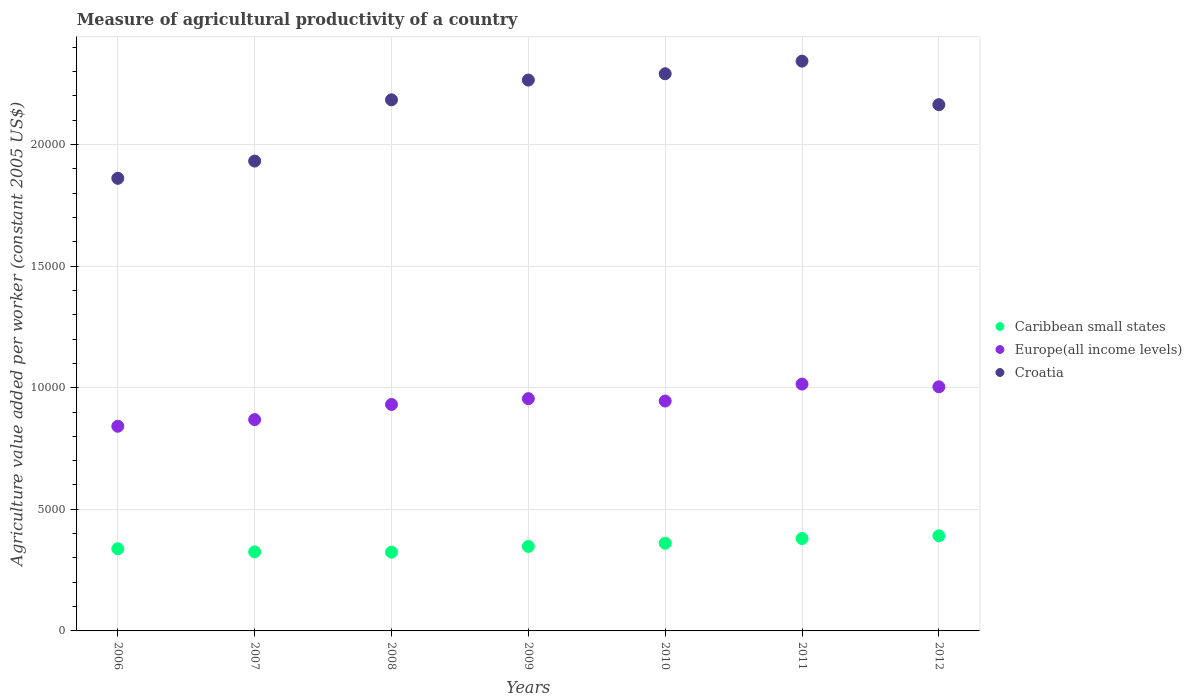How many different coloured dotlines are there?
Keep it short and to the point. 3. What is the measure of agricultural productivity in Europe(all income levels) in 2011?
Provide a succinct answer. 1.01e+04. Across all years, what is the maximum measure of agricultural productivity in Croatia?
Give a very brief answer. 2.34e+04. Across all years, what is the minimum measure of agricultural productivity in Croatia?
Provide a short and direct response. 1.86e+04. In which year was the measure of agricultural productivity in Croatia maximum?
Give a very brief answer. 2011. In which year was the measure of agricultural productivity in Croatia minimum?
Provide a succinct answer. 2006. What is the total measure of agricultural productivity in Caribbean small states in the graph?
Provide a short and direct response. 2.47e+04. What is the difference between the measure of agricultural productivity in Caribbean small states in 2006 and that in 2010?
Ensure brevity in your answer.  -224.67. What is the difference between the measure of agricultural productivity in Europe(all income levels) in 2006 and the measure of agricultural productivity in Caribbean small states in 2010?
Keep it short and to the point. 4811.52. What is the average measure of agricultural productivity in Europe(all income levels) per year?
Offer a very short reply. 9371.92. In the year 2006, what is the difference between the measure of agricultural productivity in Caribbean small states and measure of agricultural productivity in Europe(all income levels)?
Provide a short and direct response. -5036.19. In how many years, is the measure of agricultural productivity in Europe(all income levels) greater than 21000 US$?
Provide a succinct answer. 0. What is the ratio of the measure of agricultural productivity in Croatia in 2008 to that in 2012?
Give a very brief answer. 1.01. Is the measure of agricultural productivity in Europe(all income levels) in 2007 less than that in 2011?
Ensure brevity in your answer.  Yes. Is the difference between the measure of agricultural productivity in Caribbean small states in 2007 and 2010 greater than the difference between the measure of agricultural productivity in Europe(all income levels) in 2007 and 2010?
Keep it short and to the point. Yes. What is the difference between the highest and the second highest measure of agricultural productivity in Caribbean small states?
Offer a terse response. 111.31. What is the difference between the highest and the lowest measure of agricultural productivity in Europe(all income levels)?
Provide a short and direct response. 1733.67. Is the sum of the measure of agricultural productivity in Caribbean small states in 2007 and 2011 greater than the maximum measure of agricultural productivity in Croatia across all years?
Offer a terse response. No. Is it the case that in every year, the sum of the measure of agricultural productivity in Caribbean small states and measure of agricultural productivity in Europe(all income levels)  is greater than the measure of agricultural productivity in Croatia?
Make the answer very short. No. Is the measure of agricultural productivity in Europe(all income levels) strictly greater than the measure of agricultural productivity in Caribbean small states over the years?
Your answer should be very brief. Yes. Is the measure of agricultural productivity in Europe(all income levels) strictly less than the measure of agricultural productivity in Croatia over the years?
Make the answer very short. Yes. How many years are there in the graph?
Ensure brevity in your answer.  7. Are the values on the major ticks of Y-axis written in scientific E-notation?
Offer a very short reply. No. Does the graph contain grids?
Offer a terse response. Yes. How many legend labels are there?
Your answer should be compact. 3. What is the title of the graph?
Offer a terse response. Measure of agricultural productivity of a country. Does "Tanzania" appear as one of the legend labels in the graph?
Ensure brevity in your answer.  No. What is the label or title of the Y-axis?
Offer a very short reply. Agriculture value added per worker (constant 2005 US$). What is the Agriculture value added per worker (constant 2005 US$) of Caribbean small states in 2006?
Offer a very short reply. 3379.18. What is the Agriculture value added per worker (constant 2005 US$) in Europe(all income levels) in 2006?
Offer a terse response. 8415.37. What is the Agriculture value added per worker (constant 2005 US$) of Croatia in 2006?
Provide a short and direct response. 1.86e+04. What is the Agriculture value added per worker (constant 2005 US$) of Caribbean small states in 2007?
Offer a very short reply. 3251.7. What is the Agriculture value added per worker (constant 2005 US$) of Europe(all income levels) in 2007?
Give a very brief answer. 8688.61. What is the Agriculture value added per worker (constant 2005 US$) in Croatia in 2007?
Offer a very short reply. 1.93e+04. What is the Agriculture value added per worker (constant 2005 US$) of Caribbean small states in 2008?
Keep it short and to the point. 3238. What is the Agriculture value added per worker (constant 2005 US$) in Europe(all income levels) in 2008?
Your answer should be very brief. 9311.42. What is the Agriculture value added per worker (constant 2005 US$) in Croatia in 2008?
Provide a succinct answer. 2.18e+04. What is the Agriculture value added per worker (constant 2005 US$) of Caribbean small states in 2009?
Offer a very short reply. 3474.01. What is the Agriculture value added per worker (constant 2005 US$) of Europe(all income levels) in 2009?
Make the answer very short. 9549.65. What is the Agriculture value added per worker (constant 2005 US$) in Croatia in 2009?
Keep it short and to the point. 2.26e+04. What is the Agriculture value added per worker (constant 2005 US$) in Caribbean small states in 2010?
Offer a very short reply. 3603.85. What is the Agriculture value added per worker (constant 2005 US$) in Europe(all income levels) in 2010?
Provide a succinct answer. 9451.91. What is the Agriculture value added per worker (constant 2005 US$) of Croatia in 2010?
Give a very brief answer. 2.29e+04. What is the Agriculture value added per worker (constant 2005 US$) in Caribbean small states in 2011?
Make the answer very short. 3799.12. What is the Agriculture value added per worker (constant 2005 US$) of Europe(all income levels) in 2011?
Provide a short and direct response. 1.01e+04. What is the Agriculture value added per worker (constant 2005 US$) of Croatia in 2011?
Ensure brevity in your answer.  2.34e+04. What is the Agriculture value added per worker (constant 2005 US$) of Caribbean small states in 2012?
Give a very brief answer. 3910.42. What is the Agriculture value added per worker (constant 2005 US$) in Europe(all income levels) in 2012?
Your answer should be compact. 1.00e+04. What is the Agriculture value added per worker (constant 2005 US$) in Croatia in 2012?
Keep it short and to the point. 2.16e+04. Across all years, what is the maximum Agriculture value added per worker (constant 2005 US$) in Caribbean small states?
Your answer should be very brief. 3910.42. Across all years, what is the maximum Agriculture value added per worker (constant 2005 US$) of Europe(all income levels)?
Your answer should be compact. 1.01e+04. Across all years, what is the maximum Agriculture value added per worker (constant 2005 US$) in Croatia?
Your answer should be very brief. 2.34e+04. Across all years, what is the minimum Agriculture value added per worker (constant 2005 US$) in Caribbean small states?
Your response must be concise. 3238. Across all years, what is the minimum Agriculture value added per worker (constant 2005 US$) of Europe(all income levels)?
Make the answer very short. 8415.37. Across all years, what is the minimum Agriculture value added per worker (constant 2005 US$) in Croatia?
Your response must be concise. 1.86e+04. What is the total Agriculture value added per worker (constant 2005 US$) in Caribbean small states in the graph?
Ensure brevity in your answer.  2.47e+04. What is the total Agriculture value added per worker (constant 2005 US$) of Europe(all income levels) in the graph?
Your answer should be very brief. 6.56e+04. What is the total Agriculture value added per worker (constant 2005 US$) of Croatia in the graph?
Your answer should be compact. 1.50e+05. What is the difference between the Agriculture value added per worker (constant 2005 US$) of Caribbean small states in 2006 and that in 2007?
Make the answer very short. 127.48. What is the difference between the Agriculture value added per worker (constant 2005 US$) in Europe(all income levels) in 2006 and that in 2007?
Ensure brevity in your answer.  -273.24. What is the difference between the Agriculture value added per worker (constant 2005 US$) of Croatia in 2006 and that in 2007?
Provide a short and direct response. -709.26. What is the difference between the Agriculture value added per worker (constant 2005 US$) in Caribbean small states in 2006 and that in 2008?
Make the answer very short. 141.18. What is the difference between the Agriculture value added per worker (constant 2005 US$) in Europe(all income levels) in 2006 and that in 2008?
Your response must be concise. -896.05. What is the difference between the Agriculture value added per worker (constant 2005 US$) in Croatia in 2006 and that in 2008?
Your answer should be very brief. -3228.09. What is the difference between the Agriculture value added per worker (constant 2005 US$) of Caribbean small states in 2006 and that in 2009?
Your response must be concise. -94.83. What is the difference between the Agriculture value added per worker (constant 2005 US$) in Europe(all income levels) in 2006 and that in 2009?
Ensure brevity in your answer.  -1134.28. What is the difference between the Agriculture value added per worker (constant 2005 US$) of Croatia in 2006 and that in 2009?
Provide a short and direct response. -4039.77. What is the difference between the Agriculture value added per worker (constant 2005 US$) of Caribbean small states in 2006 and that in 2010?
Your answer should be compact. -224.67. What is the difference between the Agriculture value added per worker (constant 2005 US$) of Europe(all income levels) in 2006 and that in 2010?
Ensure brevity in your answer.  -1036.53. What is the difference between the Agriculture value added per worker (constant 2005 US$) in Croatia in 2006 and that in 2010?
Offer a very short reply. -4298.87. What is the difference between the Agriculture value added per worker (constant 2005 US$) of Caribbean small states in 2006 and that in 2011?
Provide a short and direct response. -419.94. What is the difference between the Agriculture value added per worker (constant 2005 US$) of Europe(all income levels) in 2006 and that in 2011?
Your answer should be very brief. -1733.67. What is the difference between the Agriculture value added per worker (constant 2005 US$) of Croatia in 2006 and that in 2011?
Your response must be concise. -4818.42. What is the difference between the Agriculture value added per worker (constant 2005 US$) of Caribbean small states in 2006 and that in 2012?
Your answer should be compact. -531.24. What is the difference between the Agriculture value added per worker (constant 2005 US$) in Europe(all income levels) in 2006 and that in 2012?
Your answer should be compact. -1622.05. What is the difference between the Agriculture value added per worker (constant 2005 US$) of Croatia in 2006 and that in 2012?
Provide a succinct answer. -3028.24. What is the difference between the Agriculture value added per worker (constant 2005 US$) in Caribbean small states in 2007 and that in 2008?
Offer a very short reply. 13.7. What is the difference between the Agriculture value added per worker (constant 2005 US$) in Europe(all income levels) in 2007 and that in 2008?
Your response must be concise. -622.81. What is the difference between the Agriculture value added per worker (constant 2005 US$) in Croatia in 2007 and that in 2008?
Offer a very short reply. -2518.83. What is the difference between the Agriculture value added per worker (constant 2005 US$) in Caribbean small states in 2007 and that in 2009?
Your answer should be very brief. -222.31. What is the difference between the Agriculture value added per worker (constant 2005 US$) in Europe(all income levels) in 2007 and that in 2009?
Ensure brevity in your answer.  -861.04. What is the difference between the Agriculture value added per worker (constant 2005 US$) in Croatia in 2007 and that in 2009?
Make the answer very short. -3330.51. What is the difference between the Agriculture value added per worker (constant 2005 US$) in Caribbean small states in 2007 and that in 2010?
Offer a very short reply. -352.15. What is the difference between the Agriculture value added per worker (constant 2005 US$) of Europe(all income levels) in 2007 and that in 2010?
Offer a terse response. -763.3. What is the difference between the Agriculture value added per worker (constant 2005 US$) in Croatia in 2007 and that in 2010?
Keep it short and to the point. -3589.61. What is the difference between the Agriculture value added per worker (constant 2005 US$) in Caribbean small states in 2007 and that in 2011?
Give a very brief answer. -547.41. What is the difference between the Agriculture value added per worker (constant 2005 US$) of Europe(all income levels) in 2007 and that in 2011?
Offer a terse response. -1460.43. What is the difference between the Agriculture value added per worker (constant 2005 US$) of Croatia in 2007 and that in 2011?
Your response must be concise. -4109.16. What is the difference between the Agriculture value added per worker (constant 2005 US$) in Caribbean small states in 2007 and that in 2012?
Offer a terse response. -658.72. What is the difference between the Agriculture value added per worker (constant 2005 US$) in Europe(all income levels) in 2007 and that in 2012?
Offer a very short reply. -1348.81. What is the difference between the Agriculture value added per worker (constant 2005 US$) of Croatia in 2007 and that in 2012?
Make the answer very short. -2318.98. What is the difference between the Agriculture value added per worker (constant 2005 US$) in Caribbean small states in 2008 and that in 2009?
Provide a short and direct response. -236.01. What is the difference between the Agriculture value added per worker (constant 2005 US$) of Europe(all income levels) in 2008 and that in 2009?
Keep it short and to the point. -238.23. What is the difference between the Agriculture value added per worker (constant 2005 US$) in Croatia in 2008 and that in 2009?
Ensure brevity in your answer.  -811.68. What is the difference between the Agriculture value added per worker (constant 2005 US$) in Caribbean small states in 2008 and that in 2010?
Keep it short and to the point. -365.85. What is the difference between the Agriculture value added per worker (constant 2005 US$) of Europe(all income levels) in 2008 and that in 2010?
Keep it short and to the point. -140.49. What is the difference between the Agriculture value added per worker (constant 2005 US$) in Croatia in 2008 and that in 2010?
Make the answer very short. -1070.77. What is the difference between the Agriculture value added per worker (constant 2005 US$) in Caribbean small states in 2008 and that in 2011?
Your response must be concise. -561.12. What is the difference between the Agriculture value added per worker (constant 2005 US$) in Europe(all income levels) in 2008 and that in 2011?
Ensure brevity in your answer.  -837.62. What is the difference between the Agriculture value added per worker (constant 2005 US$) of Croatia in 2008 and that in 2011?
Offer a very short reply. -1590.33. What is the difference between the Agriculture value added per worker (constant 2005 US$) in Caribbean small states in 2008 and that in 2012?
Your response must be concise. -672.42. What is the difference between the Agriculture value added per worker (constant 2005 US$) in Europe(all income levels) in 2008 and that in 2012?
Make the answer very short. -726. What is the difference between the Agriculture value added per worker (constant 2005 US$) in Croatia in 2008 and that in 2012?
Provide a short and direct response. 199.86. What is the difference between the Agriculture value added per worker (constant 2005 US$) in Caribbean small states in 2009 and that in 2010?
Make the answer very short. -129.84. What is the difference between the Agriculture value added per worker (constant 2005 US$) of Europe(all income levels) in 2009 and that in 2010?
Your response must be concise. 97.74. What is the difference between the Agriculture value added per worker (constant 2005 US$) in Croatia in 2009 and that in 2010?
Provide a succinct answer. -259.09. What is the difference between the Agriculture value added per worker (constant 2005 US$) of Caribbean small states in 2009 and that in 2011?
Your response must be concise. -325.1. What is the difference between the Agriculture value added per worker (constant 2005 US$) in Europe(all income levels) in 2009 and that in 2011?
Your answer should be compact. -599.39. What is the difference between the Agriculture value added per worker (constant 2005 US$) of Croatia in 2009 and that in 2011?
Your response must be concise. -778.64. What is the difference between the Agriculture value added per worker (constant 2005 US$) in Caribbean small states in 2009 and that in 2012?
Provide a succinct answer. -436.41. What is the difference between the Agriculture value added per worker (constant 2005 US$) in Europe(all income levels) in 2009 and that in 2012?
Your answer should be very brief. -487.77. What is the difference between the Agriculture value added per worker (constant 2005 US$) in Croatia in 2009 and that in 2012?
Ensure brevity in your answer.  1011.54. What is the difference between the Agriculture value added per worker (constant 2005 US$) in Caribbean small states in 2010 and that in 2011?
Offer a very short reply. -195.27. What is the difference between the Agriculture value added per worker (constant 2005 US$) of Europe(all income levels) in 2010 and that in 2011?
Give a very brief answer. -697.13. What is the difference between the Agriculture value added per worker (constant 2005 US$) in Croatia in 2010 and that in 2011?
Your response must be concise. -519.55. What is the difference between the Agriculture value added per worker (constant 2005 US$) in Caribbean small states in 2010 and that in 2012?
Make the answer very short. -306.57. What is the difference between the Agriculture value added per worker (constant 2005 US$) in Europe(all income levels) in 2010 and that in 2012?
Provide a short and direct response. -585.51. What is the difference between the Agriculture value added per worker (constant 2005 US$) of Croatia in 2010 and that in 2012?
Make the answer very short. 1270.63. What is the difference between the Agriculture value added per worker (constant 2005 US$) in Caribbean small states in 2011 and that in 2012?
Offer a very short reply. -111.31. What is the difference between the Agriculture value added per worker (constant 2005 US$) in Europe(all income levels) in 2011 and that in 2012?
Keep it short and to the point. 111.62. What is the difference between the Agriculture value added per worker (constant 2005 US$) in Croatia in 2011 and that in 2012?
Give a very brief answer. 1790.18. What is the difference between the Agriculture value added per worker (constant 2005 US$) in Caribbean small states in 2006 and the Agriculture value added per worker (constant 2005 US$) in Europe(all income levels) in 2007?
Your answer should be very brief. -5309.43. What is the difference between the Agriculture value added per worker (constant 2005 US$) in Caribbean small states in 2006 and the Agriculture value added per worker (constant 2005 US$) in Croatia in 2007?
Give a very brief answer. -1.59e+04. What is the difference between the Agriculture value added per worker (constant 2005 US$) of Europe(all income levels) in 2006 and the Agriculture value added per worker (constant 2005 US$) of Croatia in 2007?
Your answer should be very brief. -1.09e+04. What is the difference between the Agriculture value added per worker (constant 2005 US$) of Caribbean small states in 2006 and the Agriculture value added per worker (constant 2005 US$) of Europe(all income levels) in 2008?
Give a very brief answer. -5932.24. What is the difference between the Agriculture value added per worker (constant 2005 US$) in Caribbean small states in 2006 and the Agriculture value added per worker (constant 2005 US$) in Croatia in 2008?
Provide a succinct answer. -1.85e+04. What is the difference between the Agriculture value added per worker (constant 2005 US$) in Europe(all income levels) in 2006 and the Agriculture value added per worker (constant 2005 US$) in Croatia in 2008?
Give a very brief answer. -1.34e+04. What is the difference between the Agriculture value added per worker (constant 2005 US$) of Caribbean small states in 2006 and the Agriculture value added per worker (constant 2005 US$) of Europe(all income levels) in 2009?
Your answer should be very brief. -6170.47. What is the difference between the Agriculture value added per worker (constant 2005 US$) of Caribbean small states in 2006 and the Agriculture value added per worker (constant 2005 US$) of Croatia in 2009?
Provide a succinct answer. -1.93e+04. What is the difference between the Agriculture value added per worker (constant 2005 US$) of Europe(all income levels) in 2006 and the Agriculture value added per worker (constant 2005 US$) of Croatia in 2009?
Give a very brief answer. -1.42e+04. What is the difference between the Agriculture value added per worker (constant 2005 US$) in Caribbean small states in 2006 and the Agriculture value added per worker (constant 2005 US$) in Europe(all income levels) in 2010?
Offer a terse response. -6072.73. What is the difference between the Agriculture value added per worker (constant 2005 US$) in Caribbean small states in 2006 and the Agriculture value added per worker (constant 2005 US$) in Croatia in 2010?
Offer a terse response. -1.95e+04. What is the difference between the Agriculture value added per worker (constant 2005 US$) in Europe(all income levels) in 2006 and the Agriculture value added per worker (constant 2005 US$) in Croatia in 2010?
Offer a terse response. -1.45e+04. What is the difference between the Agriculture value added per worker (constant 2005 US$) in Caribbean small states in 2006 and the Agriculture value added per worker (constant 2005 US$) in Europe(all income levels) in 2011?
Make the answer very short. -6769.86. What is the difference between the Agriculture value added per worker (constant 2005 US$) in Caribbean small states in 2006 and the Agriculture value added per worker (constant 2005 US$) in Croatia in 2011?
Your answer should be compact. -2.00e+04. What is the difference between the Agriculture value added per worker (constant 2005 US$) of Europe(all income levels) in 2006 and the Agriculture value added per worker (constant 2005 US$) of Croatia in 2011?
Offer a very short reply. -1.50e+04. What is the difference between the Agriculture value added per worker (constant 2005 US$) in Caribbean small states in 2006 and the Agriculture value added per worker (constant 2005 US$) in Europe(all income levels) in 2012?
Offer a very short reply. -6658.24. What is the difference between the Agriculture value added per worker (constant 2005 US$) of Caribbean small states in 2006 and the Agriculture value added per worker (constant 2005 US$) of Croatia in 2012?
Keep it short and to the point. -1.83e+04. What is the difference between the Agriculture value added per worker (constant 2005 US$) of Europe(all income levels) in 2006 and the Agriculture value added per worker (constant 2005 US$) of Croatia in 2012?
Provide a short and direct response. -1.32e+04. What is the difference between the Agriculture value added per worker (constant 2005 US$) of Caribbean small states in 2007 and the Agriculture value added per worker (constant 2005 US$) of Europe(all income levels) in 2008?
Your answer should be compact. -6059.72. What is the difference between the Agriculture value added per worker (constant 2005 US$) of Caribbean small states in 2007 and the Agriculture value added per worker (constant 2005 US$) of Croatia in 2008?
Give a very brief answer. -1.86e+04. What is the difference between the Agriculture value added per worker (constant 2005 US$) in Europe(all income levels) in 2007 and the Agriculture value added per worker (constant 2005 US$) in Croatia in 2008?
Keep it short and to the point. -1.31e+04. What is the difference between the Agriculture value added per worker (constant 2005 US$) of Caribbean small states in 2007 and the Agriculture value added per worker (constant 2005 US$) of Europe(all income levels) in 2009?
Make the answer very short. -6297.95. What is the difference between the Agriculture value added per worker (constant 2005 US$) of Caribbean small states in 2007 and the Agriculture value added per worker (constant 2005 US$) of Croatia in 2009?
Your response must be concise. -1.94e+04. What is the difference between the Agriculture value added per worker (constant 2005 US$) in Europe(all income levels) in 2007 and the Agriculture value added per worker (constant 2005 US$) in Croatia in 2009?
Keep it short and to the point. -1.40e+04. What is the difference between the Agriculture value added per worker (constant 2005 US$) of Caribbean small states in 2007 and the Agriculture value added per worker (constant 2005 US$) of Europe(all income levels) in 2010?
Keep it short and to the point. -6200.2. What is the difference between the Agriculture value added per worker (constant 2005 US$) in Caribbean small states in 2007 and the Agriculture value added per worker (constant 2005 US$) in Croatia in 2010?
Your answer should be compact. -1.97e+04. What is the difference between the Agriculture value added per worker (constant 2005 US$) in Europe(all income levels) in 2007 and the Agriculture value added per worker (constant 2005 US$) in Croatia in 2010?
Make the answer very short. -1.42e+04. What is the difference between the Agriculture value added per worker (constant 2005 US$) of Caribbean small states in 2007 and the Agriculture value added per worker (constant 2005 US$) of Europe(all income levels) in 2011?
Keep it short and to the point. -6897.34. What is the difference between the Agriculture value added per worker (constant 2005 US$) in Caribbean small states in 2007 and the Agriculture value added per worker (constant 2005 US$) in Croatia in 2011?
Your response must be concise. -2.02e+04. What is the difference between the Agriculture value added per worker (constant 2005 US$) in Europe(all income levels) in 2007 and the Agriculture value added per worker (constant 2005 US$) in Croatia in 2011?
Your answer should be very brief. -1.47e+04. What is the difference between the Agriculture value added per worker (constant 2005 US$) in Caribbean small states in 2007 and the Agriculture value added per worker (constant 2005 US$) in Europe(all income levels) in 2012?
Offer a terse response. -6785.72. What is the difference between the Agriculture value added per worker (constant 2005 US$) in Caribbean small states in 2007 and the Agriculture value added per worker (constant 2005 US$) in Croatia in 2012?
Your answer should be compact. -1.84e+04. What is the difference between the Agriculture value added per worker (constant 2005 US$) of Europe(all income levels) in 2007 and the Agriculture value added per worker (constant 2005 US$) of Croatia in 2012?
Offer a terse response. -1.29e+04. What is the difference between the Agriculture value added per worker (constant 2005 US$) in Caribbean small states in 2008 and the Agriculture value added per worker (constant 2005 US$) in Europe(all income levels) in 2009?
Provide a succinct answer. -6311.65. What is the difference between the Agriculture value added per worker (constant 2005 US$) in Caribbean small states in 2008 and the Agriculture value added per worker (constant 2005 US$) in Croatia in 2009?
Keep it short and to the point. -1.94e+04. What is the difference between the Agriculture value added per worker (constant 2005 US$) of Europe(all income levels) in 2008 and the Agriculture value added per worker (constant 2005 US$) of Croatia in 2009?
Ensure brevity in your answer.  -1.33e+04. What is the difference between the Agriculture value added per worker (constant 2005 US$) of Caribbean small states in 2008 and the Agriculture value added per worker (constant 2005 US$) of Europe(all income levels) in 2010?
Ensure brevity in your answer.  -6213.91. What is the difference between the Agriculture value added per worker (constant 2005 US$) of Caribbean small states in 2008 and the Agriculture value added per worker (constant 2005 US$) of Croatia in 2010?
Keep it short and to the point. -1.97e+04. What is the difference between the Agriculture value added per worker (constant 2005 US$) in Europe(all income levels) in 2008 and the Agriculture value added per worker (constant 2005 US$) in Croatia in 2010?
Your answer should be compact. -1.36e+04. What is the difference between the Agriculture value added per worker (constant 2005 US$) of Caribbean small states in 2008 and the Agriculture value added per worker (constant 2005 US$) of Europe(all income levels) in 2011?
Give a very brief answer. -6911.04. What is the difference between the Agriculture value added per worker (constant 2005 US$) in Caribbean small states in 2008 and the Agriculture value added per worker (constant 2005 US$) in Croatia in 2011?
Provide a succinct answer. -2.02e+04. What is the difference between the Agriculture value added per worker (constant 2005 US$) of Europe(all income levels) in 2008 and the Agriculture value added per worker (constant 2005 US$) of Croatia in 2011?
Give a very brief answer. -1.41e+04. What is the difference between the Agriculture value added per worker (constant 2005 US$) in Caribbean small states in 2008 and the Agriculture value added per worker (constant 2005 US$) in Europe(all income levels) in 2012?
Offer a very short reply. -6799.42. What is the difference between the Agriculture value added per worker (constant 2005 US$) in Caribbean small states in 2008 and the Agriculture value added per worker (constant 2005 US$) in Croatia in 2012?
Ensure brevity in your answer.  -1.84e+04. What is the difference between the Agriculture value added per worker (constant 2005 US$) of Europe(all income levels) in 2008 and the Agriculture value added per worker (constant 2005 US$) of Croatia in 2012?
Your answer should be very brief. -1.23e+04. What is the difference between the Agriculture value added per worker (constant 2005 US$) of Caribbean small states in 2009 and the Agriculture value added per worker (constant 2005 US$) of Europe(all income levels) in 2010?
Provide a short and direct response. -5977.89. What is the difference between the Agriculture value added per worker (constant 2005 US$) of Caribbean small states in 2009 and the Agriculture value added per worker (constant 2005 US$) of Croatia in 2010?
Your answer should be compact. -1.94e+04. What is the difference between the Agriculture value added per worker (constant 2005 US$) in Europe(all income levels) in 2009 and the Agriculture value added per worker (constant 2005 US$) in Croatia in 2010?
Ensure brevity in your answer.  -1.34e+04. What is the difference between the Agriculture value added per worker (constant 2005 US$) in Caribbean small states in 2009 and the Agriculture value added per worker (constant 2005 US$) in Europe(all income levels) in 2011?
Your answer should be very brief. -6675.03. What is the difference between the Agriculture value added per worker (constant 2005 US$) of Caribbean small states in 2009 and the Agriculture value added per worker (constant 2005 US$) of Croatia in 2011?
Offer a terse response. -2.00e+04. What is the difference between the Agriculture value added per worker (constant 2005 US$) of Europe(all income levels) in 2009 and the Agriculture value added per worker (constant 2005 US$) of Croatia in 2011?
Provide a succinct answer. -1.39e+04. What is the difference between the Agriculture value added per worker (constant 2005 US$) of Caribbean small states in 2009 and the Agriculture value added per worker (constant 2005 US$) of Europe(all income levels) in 2012?
Keep it short and to the point. -6563.41. What is the difference between the Agriculture value added per worker (constant 2005 US$) of Caribbean small states in 2009 and the Agriculture value added per worker (constant 2005 US$) of Croatia in 2012?
Provide a short and direct response. -1.82e+04. What is the difference between the Agriculture value added per worker (constant 2005 US$) of Europe(all income levels) in 2009 and the Agriculture value added per worker (constant 2005 US$) of Croatia in 2012?
Your answer should be compact. -1.21e+04. What is the difference between the Agriculture value added per worker (constant 2005 US$) in Caribbean small states in 2010 and the Agriculture value added per worker (constant 2005 US$) in Europe(all income levels) in 2011?
Your answer should be very brief. -6545.19. What is the difference between the Agriculture value added per worker (constant 2005 US$) in Caribbean small states in 2010 and the Agriculture value added per worker (constant 2005 US$) in Croatia in 2011?
Offer a terse response. -1.98e+04. What is the difference between the Agriculture value added per worker (constant 2005 US$) in Europe(all income levels) in 2010 and the Agriculture value added per worker (constant 2005 US$) in Croatia in 2011?
Offer a terse response. -1.40e+04. What is the difference between the Agriculture value added per worker (constant 2005 US$) in Caribbean small states in 2010 and the Agriculture value added per worker (constant 2005 US$) in Europe(all income levels) in 2012?
Offer a very short reply. -6433.57. What is the difference between the Agriculture value added per worker (constant 2005 US$) of Caribbean small states in 2010 and the Agriculture value added per worker (constant 2005 US$) of Croatia in 2012?
Offer a terse response. -1.80e+04. What is the difference between the Agriculture value added per worker (constant 2005 US$) in Europe(all income levels) in 2010 and the Agriculture value added per worker (constant 2005 US$) in Croatia in 2012?
Give a very brief answer. -1.22e+04. What is the difference between the Agriculture value added per worker (constant 2005 US$) in Caribbean small states in 2011 and the Agriculture value added per worker (constant 2005 US$) in Europe(all income levels) in 2012?
Give a very brief answer. -6238.31. What is the difference between the Agriculture value added per worker (constant 2005 US$) in Caribbean small states in 2011 and the Agriculture value added per worker (constant 2005 US$) in Croatia in 2012?
Keep it short and to the point. -1.78e+04. What is the difference between the Agriculture value added per worker (constant 2005 US$) in Europe(all income levels) in 2011 and the Agriculture value added per worker (constant 2005 US$) in Croatia in 2012?
Your response must be concise. -1.15e+04. What is the average Agriculture value added per worker (constant 2005 US$) in Caribbean small states per year?
Your answer should be very brief. 3522.33. What is the average Agriculture value added per worker (constant 2005 US$) of Europe(all income levels) per year?
Your answer should be very brief. 9371.92. What is the average Agriculture value added per worker (constant 2005 US$) of Croatia per year?
Make the answer very short. 2.15e+04. In the year 2006, what is the difference between the Agriculture value added per worker (constant 2005 US$) in Caribbean small states and Agriculture value added per worker (constant 2005 US$) in Europe(all income levels)?
Make the answer very short. -5036.19. In the year 2006, what is the difference between the Agriculture value added per worker (constant 2005 US$) in Caribbean small states and Agriculture value added per worker (constant 2005 US$) in Croatia?
Ensure brevity in your answer.  -1.52e+04. In the year 2006, what is the difference between the Agriculture value added per worker (constant 2005 US$) in Europe(all income levels) and Agriculture value added per worker (constant 2005 US$) in Croatia?
Offer a very short reply. -1.02e+04. In the year 2007, what is the difference between the Agriculture value added per worker (constant 2005 US$) in Caribbean small states and Agriculture value added per worker (constant 2005 US$) in Europe(all income levels)?
Your answer should be compact. -5436.91. In the year 2007, what is the difference between the Agriculture value added per worker (constant 2005 US$) in Caribbean small states and Agriculture value added per worker (constant 2005 US$) in Croatia?
Your response must be concise. -1.61e+04. In the year 2007, what is the difference between the Agriculture value added per worker (constant 2005 US$) of Europe(all income levels) and Agriculture value added per worker (constant 2005 US$) of Croatia?
Give a very brief answer. -1.06e+04. In the year 2008, what is the difference between the Agriculture value added per worker (constant 2005 US$) in Caribbean small states and Agriculture value added per worker (constant 2005 US$) in Europe(all income levels)?
Offer a terse response. -6073.42. In the year 2008, what is the difference between the Agriculture value added per worker (constant 2005 US$) of Caribbean small states and Agriculture value added per worker (constant 2005 US$) of Croatia?
Offer a very short reply. -1.86e+04. In the year 2008, what is the difference between the Agriculture value added per worker (constant 2005 US$) in Europe(all income levels) and Agriculture value added per worker (constant 2005 US$) in Croatia?
Provide a succinct answer. -1.25e+04. In the year 2009, what is the difference between the Agriculture value added per worker (constant 2005 US$) in Caribbean small states and Agriculture value added per worker (constant 2005 US$) in Europe(all income levels)?
Your response must be concise. -6075.64. In the year 2009, what is the difference between the Agriculture value added per worker (constant 2005 US$) of Caribbean small states and Agriculture value added per worker (constant 2005 US$) of Croatia?
Keep it short and to the point. -1.92e+04. In the year 2009, what is the difference between the Agriculture value added per worker (constant 2005 US$) in Europe(all income levels) and Agriculture value added per worker (constant 2005 US$) in Croatia?
Your response must be concise. -1.31e+04. In the year 2010, what is the difference between the Agriculture value added per worker (constant 2005 US$) in Caribbean small states and Agriculture value added per worker (constant 2005 US$) in Europe(all income levels)?
Offer a terse response. -5848.06. In the year 2010, what is the difference between the Agriculture value added per worker (constant 2005 US$) of Caribbean small states and Agriculture value added per worker (constant 2005 US$) of Croatia?
Your answer should be compact. -1.93e+04. In the year 2010, what is the difference between the Agriculture value added per worker (constant 2005 US$) of Europe(all income levels) and Agriculture value added per worker (constant 2005 US$) of Croatia?
Give a very brief answer. -1.35e+04. In the year 2011, what is the difference between the Agriculture value added per worker (constant 2005 US$) of Caribbean small states and Agriculture value added per worker (constant 2005 US$) of Europe(all income levels)?
Your answer should be compact. -6349.92. In the year 2011, what is the difference between the Agriculture value added per worker (constant 2005 US$) of Caribbean small states and Agriculture value added per worker (constant 2005 US$) of Croatia?
Offer a terse response. -1.96e+04. In the year 2011, what is the difference between the Agriculture value added per worker (constant 2005 US$) in Europe(all income levels) and Agriculture value added per worker (constant 2005 US$) in Croatia?
Give a very brief answer. -1.33e+04. In the year 2012, what is the difference between the Agriculture value added per worker (constant 2005 US$) of Caribbean small states and Agriculture value added per worker (constant 2005 US$) of Europe(all income levels)?
Keep it short and to the point. -6127. In the year 2012, what is the difference between the Agriculture value added per worker (constant 2005 US$) of Caribbean small states and Agriculture value added per worker (constant 2005 US$) of Croatia?
Your answer should be compact. -1.77e+04. In the year 2012, what is the difference between the Agriculture value added per worker (constant 2005 US$) in Europe(all income levels) and Agriculture value added per worker (constant 2005 US$) in Croatia?
Provide a short and direct response. -1.16e+04. What is the ratio of the Agriculture value added per worker (constant 2005 US$) of Caribbean small states in 2006 to that in 2007?
Offer a very short reply. 1.04. What is the ratio of the Agriculture value added per worker (constant 2005 US$) in Europe(all income levels) in 2006 to that in 2007?
Provide a succinct answer. 0.97. What is the ratio of the Agriculture value added per worker (constant 2005 US$) of Croatia in 2006 to that in 2007?
Offer a very short reply. 0.96. What is the ratio of the Agriculture value added per worker (constant 2005 US$) of Caribbean small states in 2006 to that in 2008?
Give a very brief answer. 1.04. What is the ratio of the Agriculture value added per worker (constant 2005 US$) in Europe(all income levels) in 2006 to that in 2008?
Your answer should be very brief. 0.9. What is the ratio of the Agriculture value added per worker (constant 2005 US$) in Croatia in 2006 to that in 2008?
Offer a very short reply. 0.85. What is the ratio of the Agriculture value added per worker (constant 2005 US$) of Caribbean small states in 2006 to that in 2009?
Make the answer very short. 0.97. What is the ratio of the Agriculture value added per worker (constant 2005 US$) in Europe(all income levels) in 2006 to that in 2009?
Your response must be concise. 0.88. What is the ratio of the Agriculture value added per worker (constant 2005 US$) in Croatia in 2006 to that in 2009?
Offer a terse response. 0.82. What is the ratio of the Agriculture value added per worker (constant 2005 US$) of Caribbean small states in 2006 to that in 2010?
Offer a terse response. 0.94. What is the ratio of the Agriculture value added per worker (constant 2005 US$) of Europe(all income levels) in 2006 to that in 2010?
Give a very brief answer. 0.89. What is the ratio of the Agriculture value added per worker (constant 2005 US$) of Croatia in 2006 to that in 2010?
Your answer should be compact. 0.81. What is the ratio of the Agriculture value added per worker (constant 2005 US$) of Caribbean small states in 2006 to that in 2011?
Offer a very short reply. 0.89. What is the ratio of the Agriculture value added per worker (constant 2005 US$) of Europe(all income levels) in 2006 to that in 2011?
Keep it short and to the point. 0.83. What is the ratio of the Agriculture value added per worker (constant 2005 US$) in Croatia in 2006 to that in 2011?
Your answer should be compact. 0.79. What is the ratio of the Agriculture value added per worker (constant 2005 US$) of Caribbean small states in 2006 to that in 2012?
Offer a very short reply. 0.86. What is the ratio of the Agriculture value added per worker (constant 2005 US$) of Europe(all income levels) in 2006 to that in 2012?
Your response must be concise. 0.84. What is the ratio of the Agriculture value added per worker (constant 2005 US$) of Croatia in 2006 to that in 2012?
Make the answer very short. 0.86. What is the ratio of the Agriculture value added per worker (constant 2005 US$) in Europe(all income levels) in 2007 to that in 2008?
Provide a succinct answer. 0.93. What is the ratio of the Agriculture value added per worker (constant 2005 US$) of Croatia in 2007 to that in 2008?
Offer a very short reply. 0.88. What is the ratio of the Agriculture value added per worker (constant 2005 US$) in Caribbean small states in 2007 to that in 2009?
Make the answer very short. 0.94. What is the ratio of the Agriculture value added per worker (constant 2005 US$) of Europe(all income levels) in 2007 to that in 2009?
Give a very brief answer. 0.91. What is the ratio of the Agriculture value added per worker (constant 2005 US$) in Croatia in 2007 to that in 2009?
Your answer should be compact. 0.85. What is the ratio of the Agriculture value added per worker (constant 2005 US$) of Caribbean small states in 2007 to that in 2010?
Offer a very short reply. 0.9. What is the ratio of the Agriculture value added per worker (constant 2005 US$) in Europe(all income levels) in 2007 to that in 2010?
Offer a terse response. 0.92. What is the ratio of the Agriculture value added per worker (constant 2005 US$) in Croatia in 2007 to that in 2010?
Give a very brief answer. 0.84. What is the ratio of the Agriculture value added per worker (constant 2005 US$) in Caribbean small states in 2007 to that in 2011?
Offer a very short reply. 0.86. What is the ratio of the Agriculture value added per worker (constant 2005 US$) in Europe(all income levels) in 2007 to that in 2011?
Ensure brevity in your answer.  0.86. What is the ratio of the Agriculture value added per worker (constant 2005 US$) in Croatia in 2007 to that in 2011?
Keep it short and to the point. 0.82. What is the ratio of the Agriculture value added per worker (constant 2005 US$) in Caribbean small states in 2007 to that in 2012?
Give a very brief answer. 0.83. What is the ratio of the Agriculture value added per worker (constant 2005 US$) of Europe(all income levels) in 2007 to that in 2012?
Give a very brief answer. 0.87. What is the ratio of the Agriculture value added per worker (constant 2005 US$) in Croatia in 2007 to that in 2012?
Keep it short and to the point. 0.89. What is the ratio of the Agriculture value added per worker (constant 2005 US$) in Caribbean small states in 2008 to that in 2009?
Ensure brevity in your answer.  0.93. What is the ratio of the Agriculture value added per worker (constant 2005 US$) in Europe(all income levels) in 2008 to that in 2009?
Keep it short and to the point. 0.98. What is the ratio of the Agriculture value added per worker (constant 2005 US$) in Croatia in 2008 to that in 2009?
Offer a terse response. 0.96. What is the ratio of the Agriculture value added per worker (constant 2005 US$) in Caribbean small states in 2008 to that in 2010?
Provide a short and direct response. 0.9. What is the ratio of the Agriculture value added per worker (constant 2005 US$) in Europe(all income levels) in 2008 to that in 2010?
Provide a short and direct response. 0.99. What is the ratio of the Agriculture value added per worker (constant 2005 US$) in Croatia in 2008 to that in 2010?
Your answer should be very brief. 0.95. What is the ratio of the Agriculture value added per worker (constant 2005 US$) in Caribbean small states in 2008 to that in 2011?
Keep it short and to the point. 0.85. What is the ratio of the Agriculture value added per worker (constant 2005 US$) in Europe(all income levels) in 2008 to that in 2011?
Your answer should be very brief. 0.92. What is the ratio of the Agriculture value added per worker (constant 2005 US$) in Croatia in 2008 to that in 2011?
Give a very brief answer. 0.93. What is the ratio of the Agriculture value added per worker (constant 2005 US$) in Caribbean small states in 2008 to that in 2012?
Keep it short and to the point. 0.83. What is the ratio of the Agriculture value added per worker (constant 2005 US$) in Europe(all income levels) in 2008 to that in 2012?
Offer a very short reply. 0.93. What is the ratio of the Agriculture value added per worker (constant 2005 US$) in Croatia in 2008 to that in 2012?
Give a very brief answer. 1.01. What is the ratio of the Agriculture value added per worker (constant 2005 US$) of Europe(all income levels) in 2009 to that in 2010?
Offer a very short reply. 1.01. What is the ratio of the Agriculture value added per worker (constant 2005 US$) of Croatia in 2009 to that in 2010?
Provide a short and direct response. 0.99. What is the ratio of the Agriculture value added per worker (constant 2005 US$) of Caribbean small states in 2009 to that in 2011?
Your response must be concise. 0.91. What is the ratio of the Agriculture value added per worker (constant 2005 US$) in Europe(all income levels) in 2009 to that in 2011?
Provide a succinct answer. 0.94. What is the ratio of the Agriculture value added per worker (constant 2005 US$) in Croatia in 2009 to that in 2011?
Your response must be concise. 0.97. What is the ratio of the Agriculture value added per worker (constant 2005 US$) in Caribbean small states in 2009 to that in 2012?
Your answer should be compact. 0.89. What is the ratio of the Agriculture value added per worker (constant 2005 US$) in Europe(all income levels) in 2009 to that in 2012?
Offer a very short reply. 0.95. What is the ratio of the Agriculture value added per worker (constant 2005 US$) in Croatia in 2009 to that in 2012?
Offer a terse response. 1.05. What is the ratio of the Agriculture value added per worker (constant 2005 US$) of Caribbean small states in 2010 to that in 2011?
Give a very brief answer. 0.95. What is the ratio of the Agriculture value added per worker (constant 2005 US$) of Europe(all income levels) in 2010 to that in 2011?
Provide a succinct answer. 0.93. What is the ratio of the Agriculture value added per worker (constant 2005 US$) in Croatia in 2010 to that in 2011?
Your answer should be very brief. 0.98. What is the ratio of the Agriculture value added per worker (constant 2005 US$) of Caribbean small states in 2010 to that in 2012?
Your answer should be compact. 0.92. What is the ratio of the Agriculture value added per worker (constant 2005 US$) in Europe(all income levels) in 2010 to that in 2012?
Ensure brevity in your answer.  0.94. What is the ratio of the Agriculture value added per worker (constant 2005 US$) in Croatia in 2010 to that in 2012?
Your response must be concise. 1.06. What is the ratio of the Agriculture value added per worker (constant 2005 US$) of Caribbean small states in 2011 to that in 2012?
Your answer should be compact. 0.97. What is the ratio of the Agriculture value added per worker (constant 2005 US$) of Europe(all income levels) in 2011 to that in 2012?
Keep it short and to the point. 1.01. What is the ratio of the Agriculture value added per worker (constant 2005 US$) of Croatia in 2011 to that in 2012?
Give a very brief answer. 1.08. What is the difference between the highest and the second highest Agriculture value added per worker (constant 2005 US$) of Caribbean small states?
Keep it short and to the point. 111.31. What is the difference between the highest and the second highest Agriculture value added per worker (constant 2005 US$) in Europe(all income levels)?
Provide a succinct answer. 111.62. What is the difference between the highest and the second highest Agriculture value added per worker (constant 2005 US$) of Croatia?
Make the answer very short. 519.55. What is the difference between the highest and the lowest Agriculture value added per worker (constant 2005 US$) of Caribbean small states?
Your answer should be compact. 672.42. What is the difference between the highest and the lowest Agriculture value added per worker (constant 2005 US$) in Europe(all income levels)?
Keep it short and to the point. 1733.67. What is the difference between the highest and the lowest Agriculture value added per worker (constant 2005 US$) in Croatia?
Ensure brevity in your answer.  4818.42. 